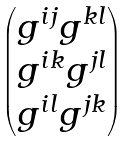Convert formula to latex. <formula><loc_0><loc_0><loc_500><loc_500>\begin{pmatrix} g ^ { i j } g ^ { k l } \\ g ^ { i k } g ^ { j l } \\ g ^ { i l } g ^ { j k } \end{pmatrix}</formula> 